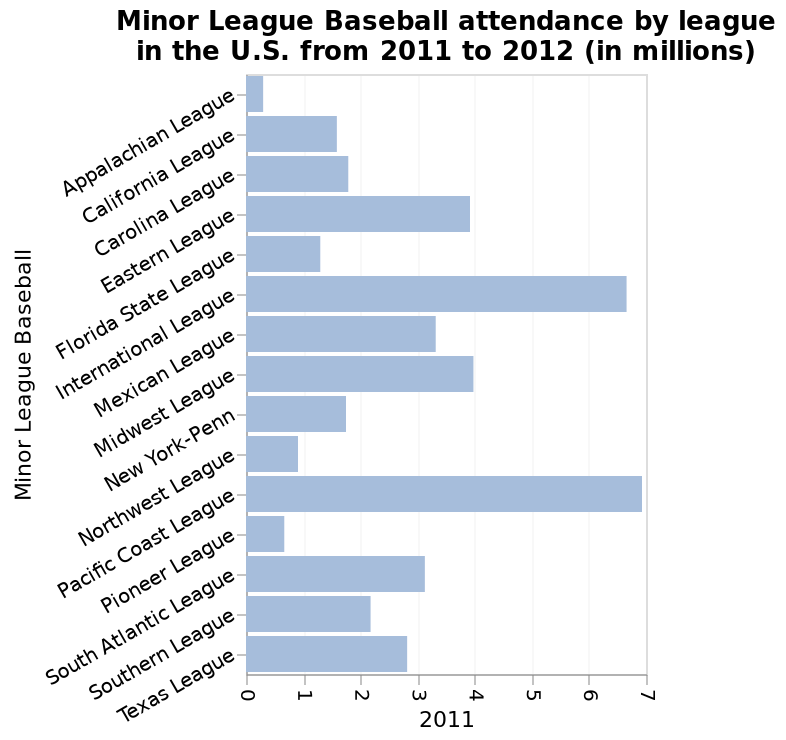<image>
How many people attended games in the Pacific Coast League?  Around 7 million people attended games in the Pacific Coast League. What was the difference in attendance between the Pacific Coast League and the Appalachian League? The difference in attendance between the Pacific Coast League and the Appalachian League was around 6.5 million. Was the difference in attendance between the Pacific Coast League and the Appalachian League exactly 6.5 million? No.The difference in attendance between the Pacific Coast League and the Appalachian League was around 6.5 million. 